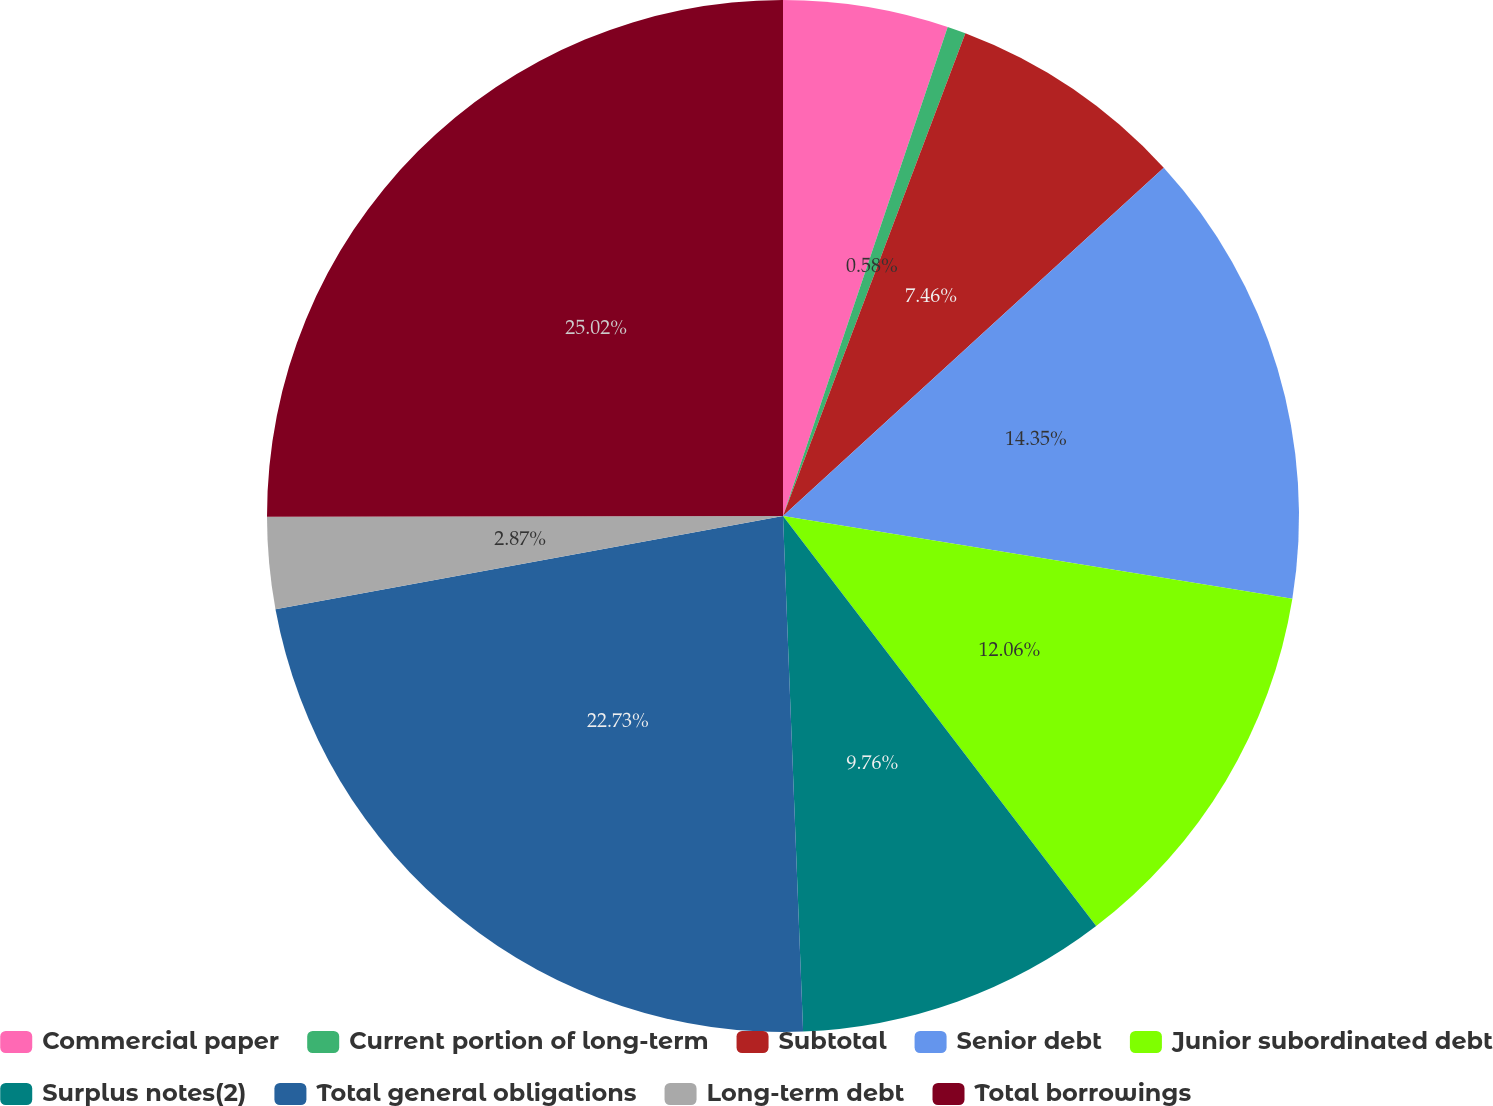<chart> <loc_0><loc_0><loc_500><loc_500><pie_chart><fcel>Commercial paper<fcel>Current portion of long-term<fcel>Subtotal<fcel>Senior debt<fcel>Junior subordinated debt<fcel>Surplus notes(2)<fcel>Total general obligations<fcel>Long-term debt<fcel>Total borrowings<nl><fcel>5.17%<fcel>0.58%<fcel>7.46%<fcel>14.35%<fcel>12.06%<fcel>9.76%<fcel>22.73%<fcel>2.87%<fcel>25.02%<nl></chart> 